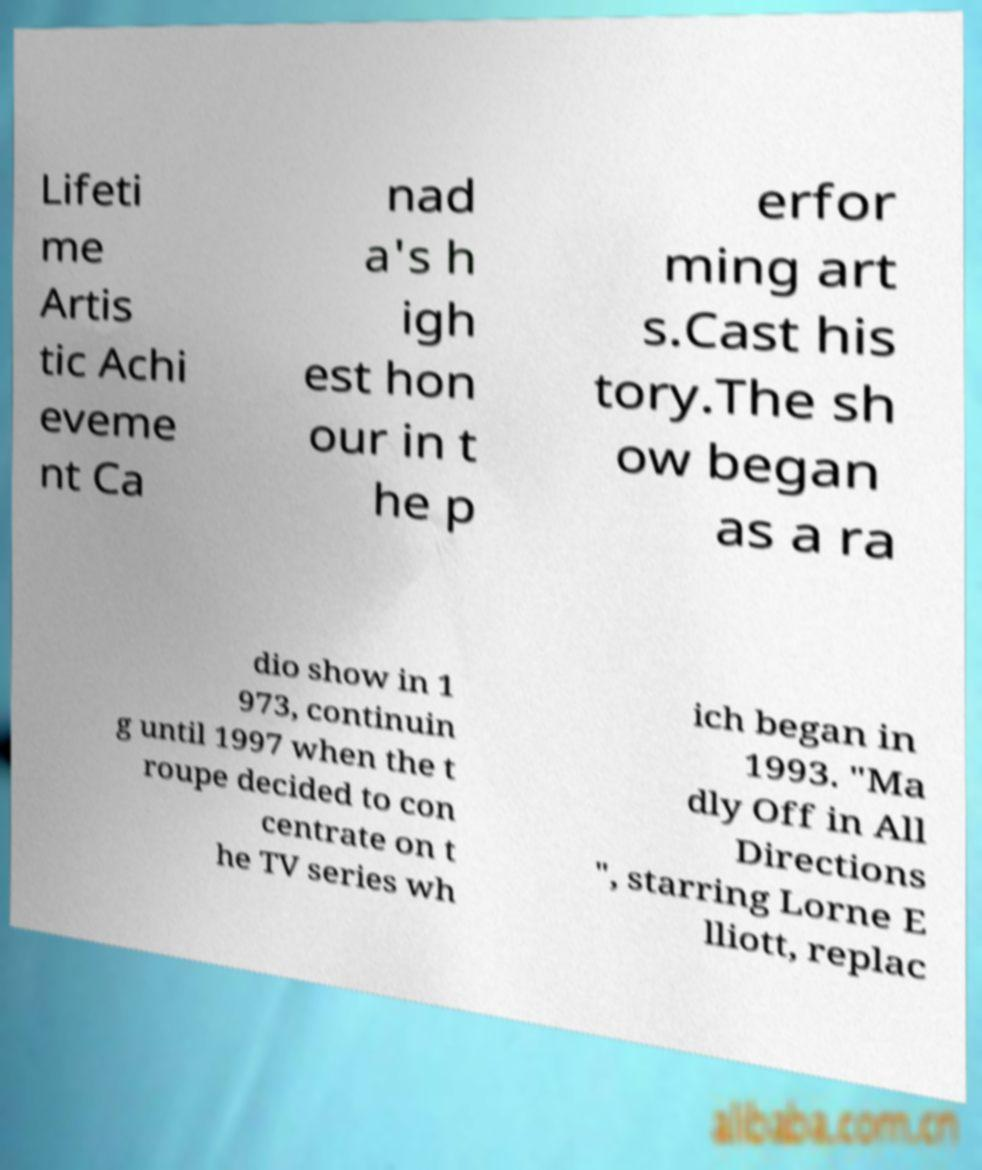Can you accurately transcribe the text from the provided image for me? Lifeti me Artis tic Achi eveme nt Ca nad a's h igh est hon our in t he p erfor ming art s.Cast his tory.The sh ow began as a ra dio show in 1 973, continuin g until 1997 when the t roupe decided to con centrate on t he TV series wh ich began in 1993. "Ma dly Off in All Directions ", starring Lorne E lliott, replac 